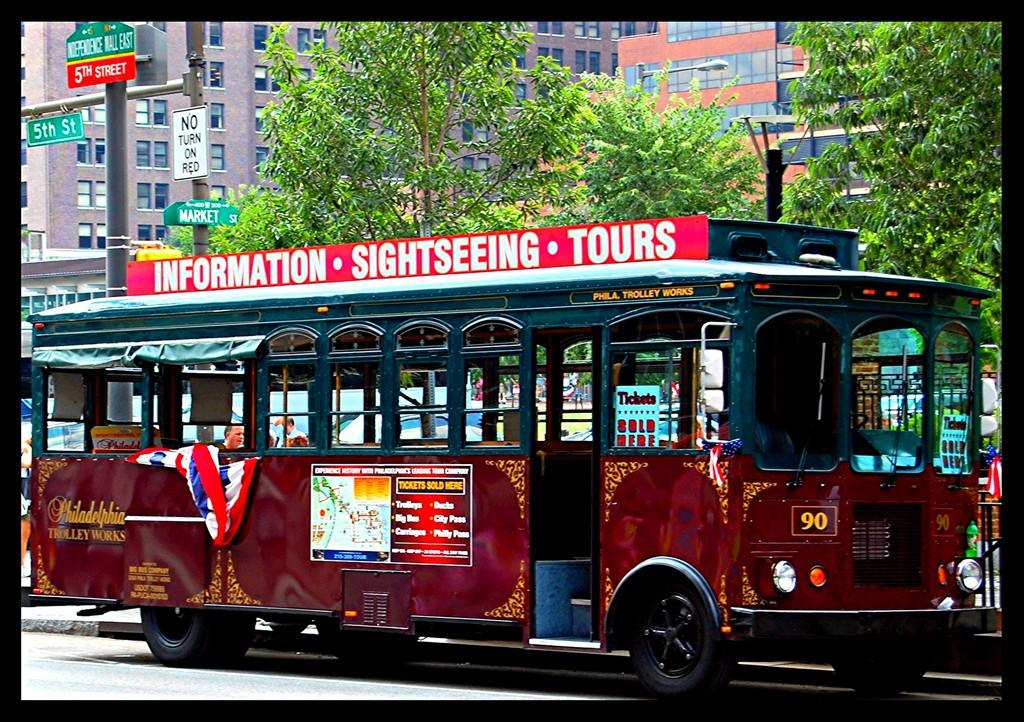What is on the road in the image? There is a vehicle on the road in the image. What objects can be seen besides the vehicle? There are boards, poles, trees, and buildings in the image. Can you describe the surroundings of the vehicle? The vehicle is surrounded by boards, poles, and trees. In the background, there are buildings. What type of berry can be seen growing on the poles in the image? There are no berries visible on the poles in the image. 